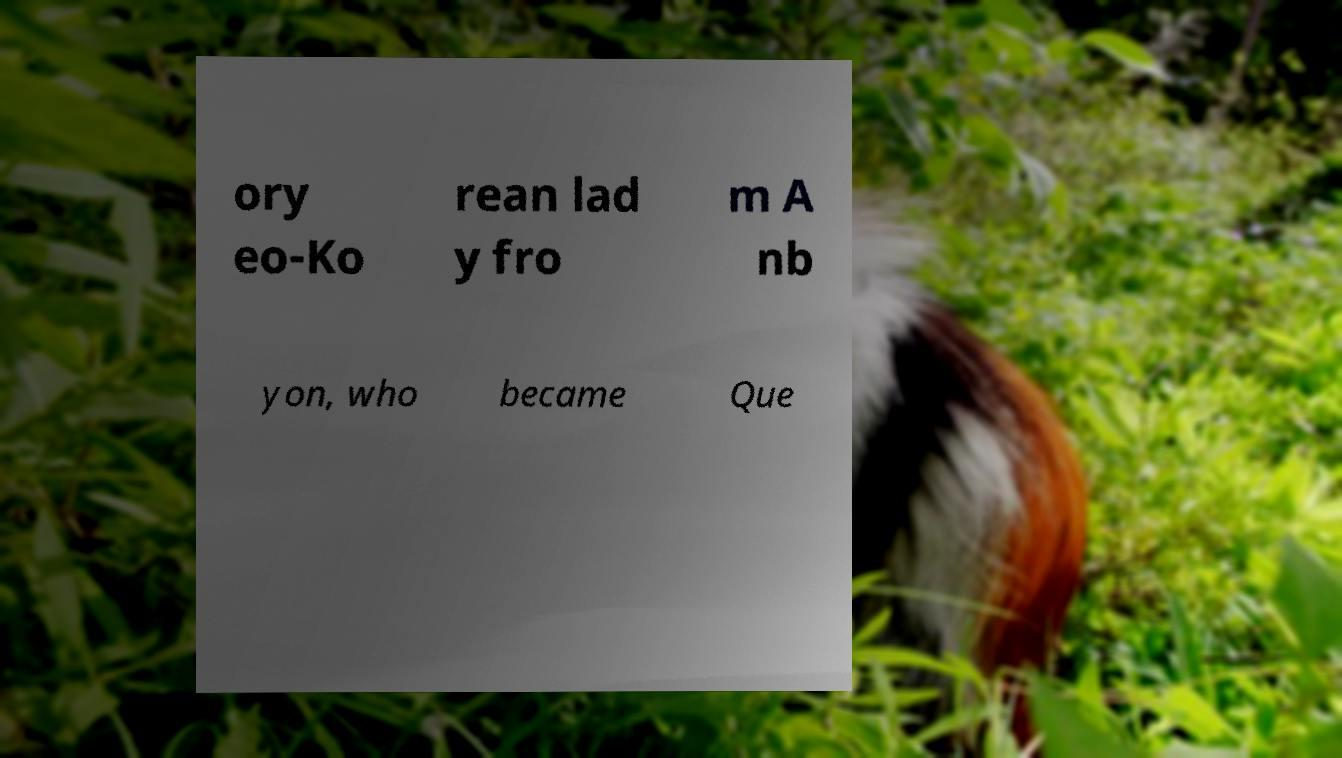Can you read and provide the text displayed in the image?This photo seems to have some interesting text. Can you extract and type it out for me? ory eo-Ko rean lad y fro m A nb yon, who became Que 